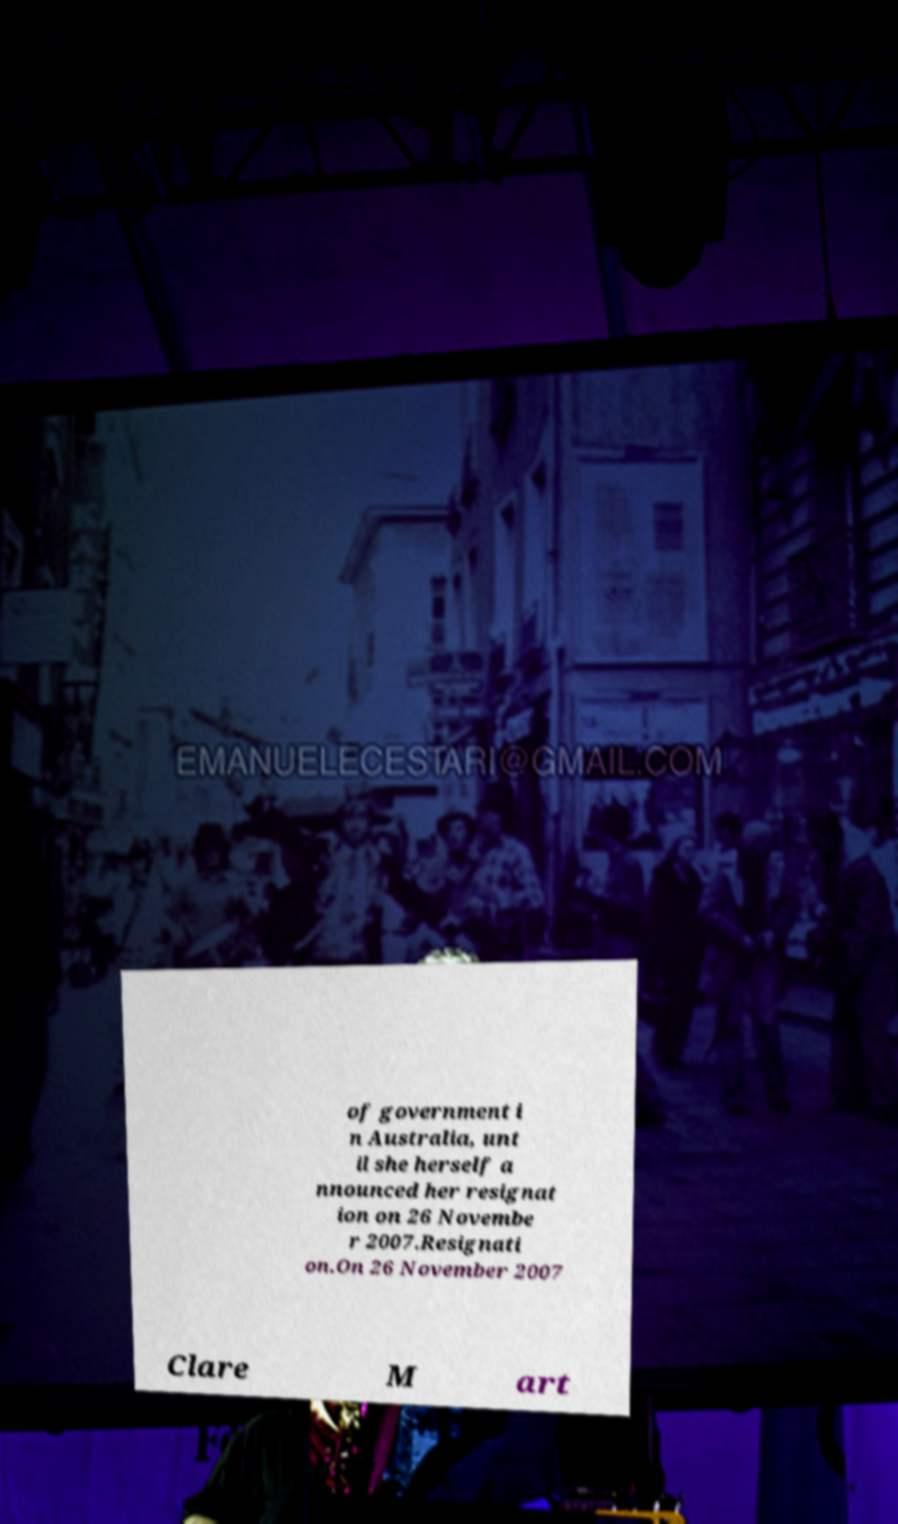There's text embedded in this image that I need extracted. Can you transcribe it verbatim? of government i n Australia, unt il she herself a nnounced her resignat ion on 26 Novembe r 2007.Resignati on.On 26 November 2007 Clare M art 